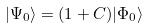Convert formula to latex. <formula><loc_0><loc_0><loc_500><loc_500>| \Psi _ { 0 } \rangle = ( 1 + C ) | \Phi _ { 0 } \rangle</formula> 